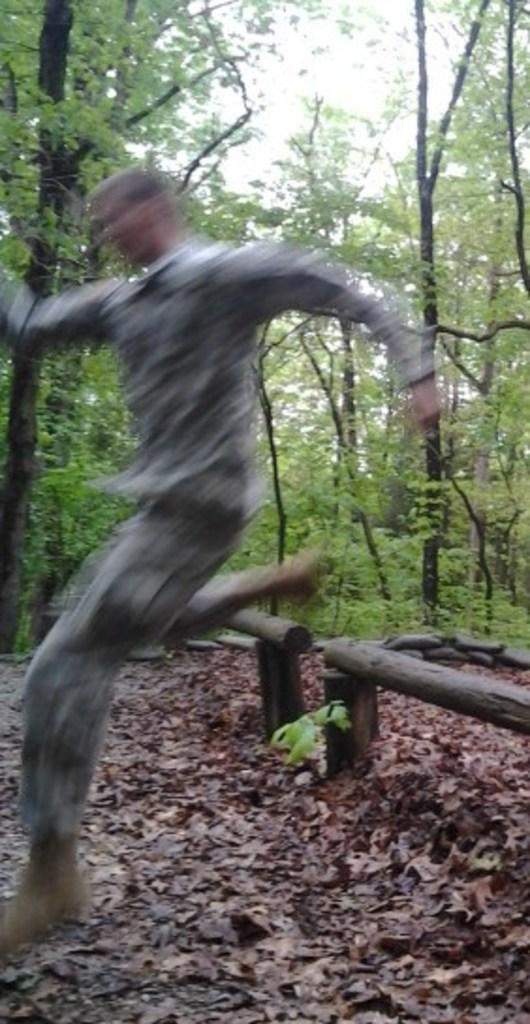What type of vegetation can be seen in the image? There are trees and plants in the image. What material are some of the objects made of in the image? There are wooden objects in the image. What is present on the ground in the image? Dry leaves are present in the image. What is the person in the image doing? It appears that a person is in the air. What can be seen in the background of the image? The sky is visible in the background of the image. What is the title of the image? There is no title provided for the image. How does the person in the image express disgust? There is no indication of disgust in the image; the person is simply in the air. 